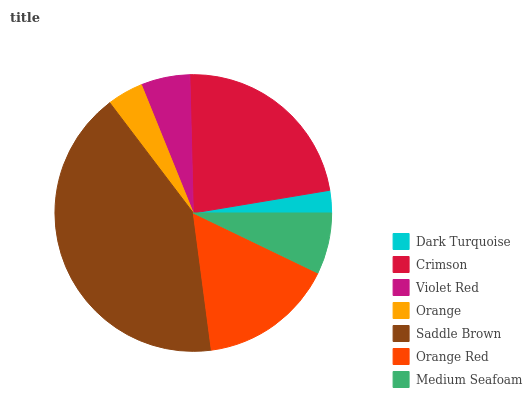Is Dark Turquoise the minimum?
Answer yes or no. Yes. Is Saddle Brown the maximum?
Answer yes or no. Yes. Is Crimson the minimum?
Answer yes or no. No. Is Crimson the maximum?
Answer yes or no. No. Is Crimson greater than Dark Turquoise?
Answer yes or no. Yes. Is Dark Turquoise less than Crimson?
Answer yes or no. Yes. Is Dark Turquoise greater than Crimson?
Answer yes or no. No. Is Crimson less than Dark Turquoise?
Answer yes or no. No. Is Medium Seafoam the high median?
Answer yes or no. Yes. Is Medium Seafoam the low median?
Answer yes or no. Yes. Is Orange the high median?
Answer yes or no. No. Is Dark Turquoise the low median?
Answer yes or no. No. 